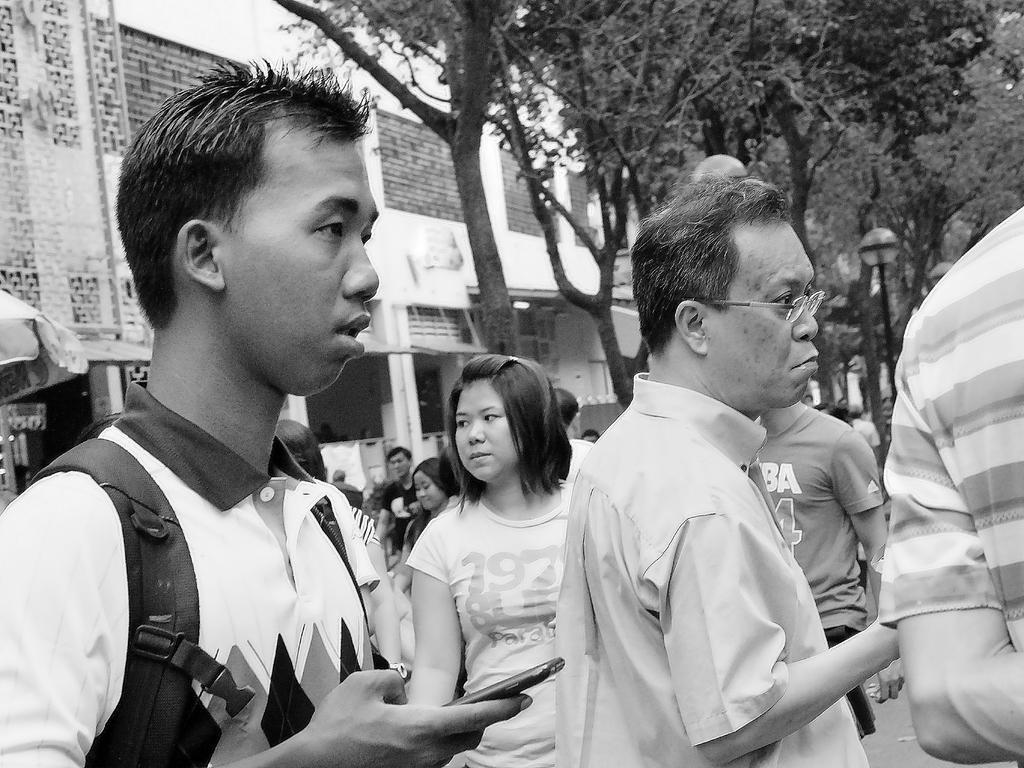How would you summarize this image in a sentence or two? In this image I can see people standing in the front. There are trees, pole and buildings at the back. This is a black and white image. 